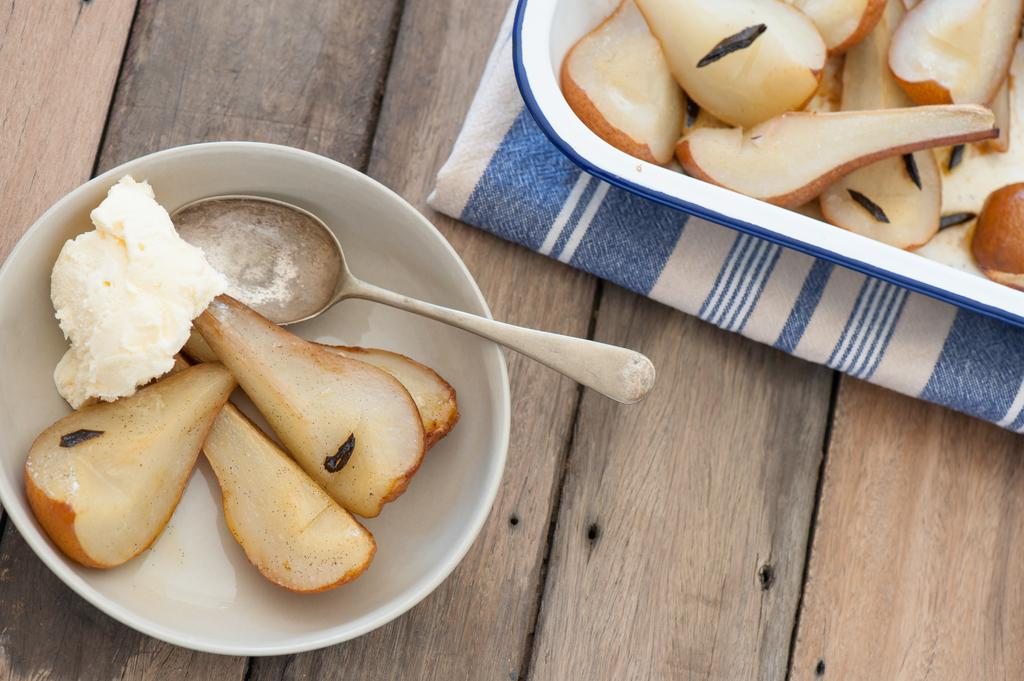What is the main structure visible in the image? There is a platform in the image. What is placed on the platform? There is a plate with food items on the platform. What is the plate resting on? The plate is on a cloth. What other food item can be seen in the image? There is a bowl with food items in the image. What utensil is present in the bowl? There is a spoon in the bowl. What type of cheese is being cut by the finger in the image? There is no cheese or finger present in the image. 